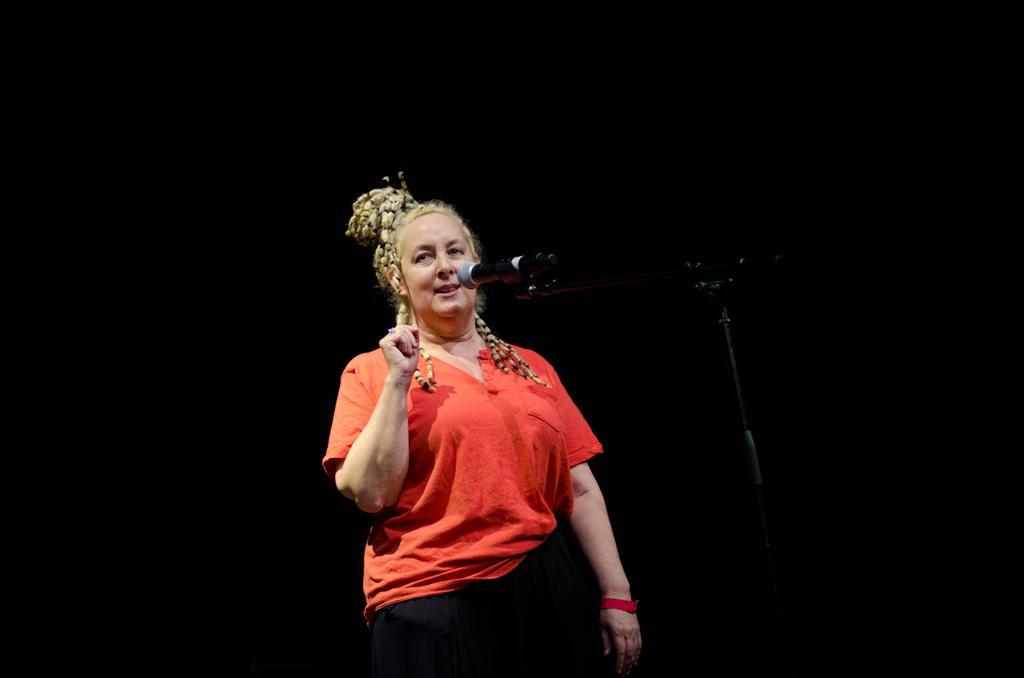Could you give a brief overview of what you see in this image? In this picture we can see a woman standing. We can see a microphone and a stand. Background portion of the picture is completely dark. 